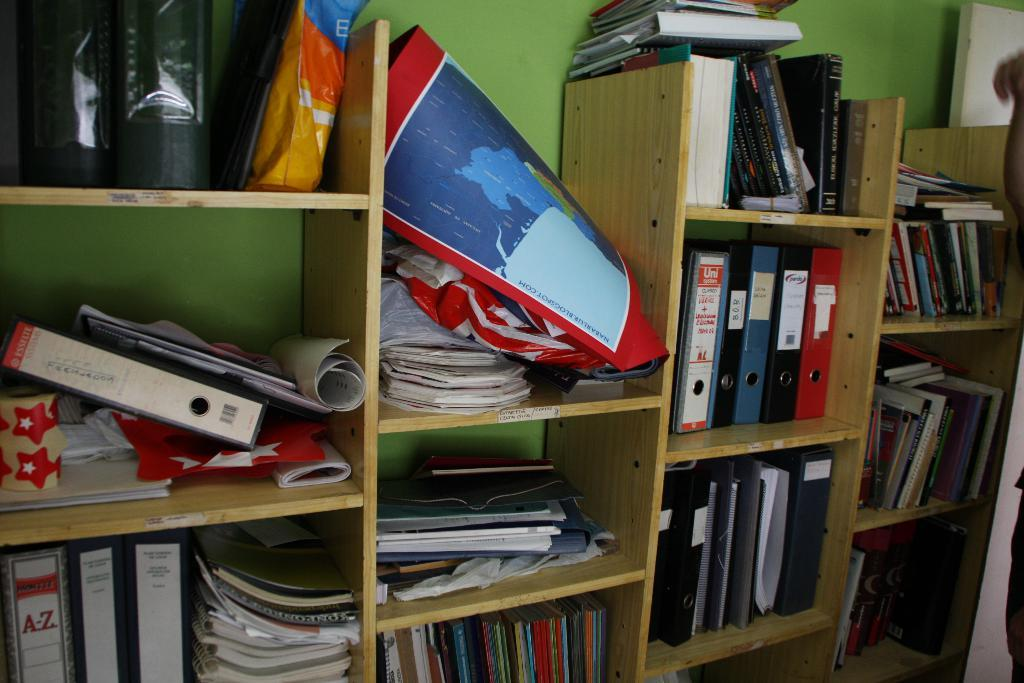<image>
Offer a succinct explanation of the picture presented. Several binders, one with A-Z written on it, can be seen sitting on shelf 